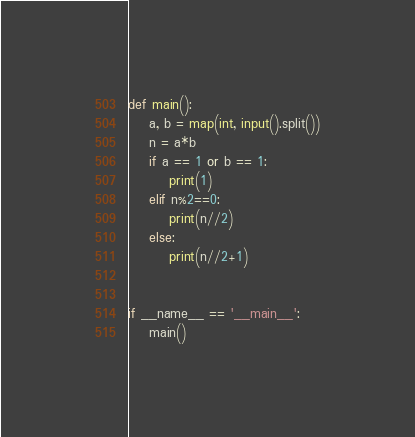Convert code to text. <code><loc_0><loc_0><loc_500><loc_500><_Python_>def main():
    a, b = map(int, input().split())
    n = a*b
    if a == 1 or b == 1:
        print(1)
    elif n%2==0:
        print(n//2)
    else:
        print(n//2+1)


if __name__ == '__main__':
    main()
</code> 